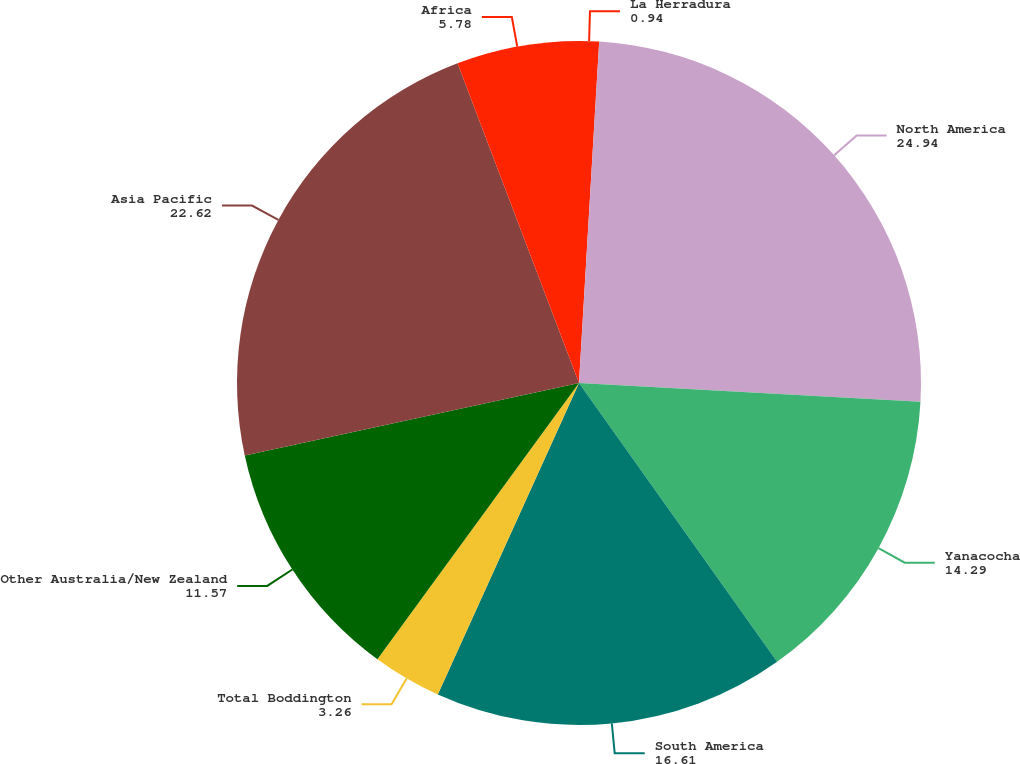Convert chart to OTSL. <chart><loc_0><loc_0><loc_500><loc_500><pie_chart><fcel>La Herradura<fcel>North America<fcel>Yanacocha<fcel>South America<fcel>Total Boddington<fcel>Other Australia/New Zealand<fcel>Asia Pacific<fcel>Africa<nl><fcel>0.94%<fcel>24.94%<fcel>14.29%<fcel>16.61%<fcel>3.26%<fcel>11.57%<fcel>22.62%<fcel>5.78%<nl></chart> 